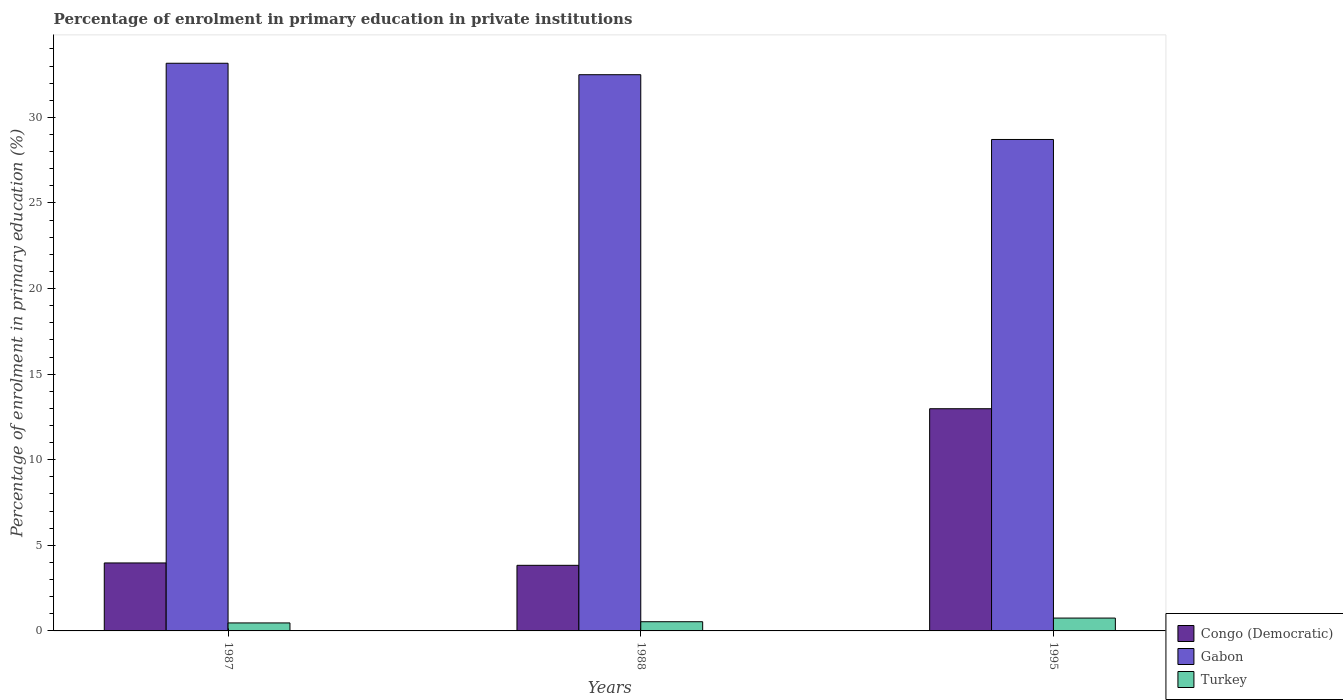Are the number of bars per tick equal to the number of legend labels?
Give a very brief answer. Yes. Are the number of bars on each tick of the X-axis equal?
Offer a very short reply. Yes. How many bars are there on the 1st tick from the right?
Provide a succinct answer. 3. In how many cases, is the number of bars for a given year not equal to the number of legend labels?
Your answer should be compact. 0. What is the percentage of enrolment in primary education in Congo (Democratic) in 1988?
Offer a very short reply. 3.83. Across all years, what is the maximum percentage of enrolment in primary education in Congo (Democratic)?
Provide a succinct answer. 12.98. Across all years, what is the minimum percentage of enrolment in primary education in Congo (Democratic)?
Your answer should be compact. 3.83. In which year was the percentage of enrolment in primary education in Gabon maximum?
Your response must be concise. 1987. What is the total percentage of enrolment in primary education in Congo (Democratic) in the graph?
Keep it short and to the point. 20.78. What is the difference between the percentage of enrolment in primary education in Gabon in 1988 and that in 1995?
Make the answer very short. 3.78. What is the difference between the percentage of enrolment in primary education in Gabon in 1987 and the percentage of enrolment in primary education in Congo (Democratic) in 1995?
Ensure brevity in your answer.  20.18. What is the average percentage of enrolment in primary education in Gabon per year?
Provide a short and direct response. 31.45. In the year 1995, what is the difference between the percentage of enrolment in primary education in Gabon and percentage of enrolment in primary education in Congo (Democratic)?
Give a very brief answer. 15.73. In how many years, is the percentage of enrolment in primary education in Turkey greater than 22 %?
Ensure brevity in your answer.  0. What is the ratio of the percentage of enrolment in primary education in Congo (Democratic) in 1987 to that in 1988?
Provide a succinct answer. 1.04. Is the difference between the percentage of enrolment in primary education in Gabon in 1987 and 1995 greater than the difference between the percentage of enrolment in primary education in Congo (Democratic) in 1987 and 1995?
Your answer should be very brief. Yes. What is the difference between the highest and the second highest percentage of enrolment in primary education in Gabon?
Offer a very short reply. 0.67. What is the difference between the highest and the lowest percentage of enrolment in primary education in Congo (Democratic)?
Your answer should be very brief. 9.15. What does the 1st bar from the left in 1995 represents?
Offer a terse response. Congo (Democratic). What does the 2nd bar from the right in 1995 represents?
Provide a short and direct response. Gabon. Is it the case that in every year, the sum of the percentage of enrolment in primary education in Turkey and percentage of enrolment in primary education in Gabon is greater than the percentage of enrolment in primary education in Congo (Democratic)?
Your answer should be compact. Yes. How many bars are there?
Provide a short and direct response. 9. Are all the bars in the graph horizontal?
Provide a succinct answer. No. What is the difference between two consecutive major ticks on the Y-axis?
Make the answer very short. 5. Does the graph contain grids?
Offer a very short reply. No. How many legend labels are there?
Keep it short and to the point. 3. How are the legend labels stacked?
Ensure brevity in your answer.  Vertical. What is the title of the graph?
Ensure brevity in your answer.  Percentage of enrolment in primary education in private institutions. What is the label or title of the Y-axis?
Provide a succinct answer. Percentage of enrolment in primary education (%). What is the Percentage of enrolment in primary education (%) of Congo (Democratic) in 1987?
Provide a succinct answer. 3.97. What is the Percentage of enrolment in primary education (%) in Gabon in 1987?
Your answer should be very brief. 33.16. What is the Percentage of enrolment in primary education (%) in Turkey in 1987?
Keep it short and to the point. 0.47. What is the Percentage of enrolment in primary education (%) in Congo (Democratic) in 1988?
Your answer should be compact. 3.83. What is the Percentage of enrolment in primary education (%) in Gabon in 1988?
Offer a very short reply. 32.49. What is the Percentage of enrolment in primary education (%) of Turkey in 1988?
Provide a succinct answer. 0.54. What is the Percentage of enrolment in primary education (%) of Congo (Democratic) in 1995?
Your answer should be very brief. 12.98. What is the Percentage of enrolment in primary education (%) of Gabon in 1995?
Offer a very short reply. 28.71. What is the Percentage of enrolment in primary education (%) of Turkey in 1995?
Provide a succinct answer. 0.75. Across all years, what is the maximum Percentage of enrolment in primary education (%) of Congo (Democratic)?
Make the answer very short. 12.98. Across all years, what is the maximum Percentage of enrolment in primary education (%) in Gabon?
Ensure brevity in your answer.  33.16. Across all years, what is the maximum Percentage of enrolment in primary education (%) in Turkey?
Provide a succinct answer. 0.75. Across all years, what is the minimum Percentage of enrolment in primary education (%) in Congo (Democratic)?
Keep it short and to the point. 3.83. Across all years, what is the minimum Percentage of enrolment in primary education (%) of Gabon?
Your answer should be compact. 28.71. Across all years, what is the minimum Percentage of enrolment in primary education (%) in Turkey?
Offer a terse response. 0.47. What is the total Percentage of enrolment in primary education (%) in Congo (Democratic) in the graph?
Make the answer very short. 20.78. What is the total Percentage of enrolment in primary education (%) in Gabon in the graph?
Ensure brevity in your answer.  94.36. What is the total Percentage of enrolment in primary education (%) in Turkey in the graph?
Provide a succinct answer. 1.75. What is the difference between the Percentage of enrolment in primary education (%) of Congo (Democratic) in 1987 and that in 1988?
Give a very brief answer. 0.14. What is the difference between the Percentage of enrolment in primary education (%) in Gabon in 1987 and that in 1988?
Provide a succinct answer. 0.67. What is the difference between the Percentage of enrolment in primary education (%) in Turkey in 1987 and that in 1988?
Offer a very short reply. -0.07. What is the difference between the Percentage of enrolment in primary education (%) of Congo (Democratic) in 1987 and that in 1995?
Ensure brevity in your answer.  -9.01. What is the difference between the Percentage of enrolment in primary education (%) of Gabon in 1987 and that in 1995?
Keep it short and to the point. 4.45. What is the difference between the Percentage of enrolment in primary education (%) in Turkey in 1987 and that in 1995?
Your response must be concise. -0.28. What is the difference between the Percentage of enrolment in primary education (%) in Congo (Democratic) in 1988 and that in 1995?
Provide a short and direct response. -9.15. What is the difference between the Percentage of enrolment in primary education (%) of Gabon in 1988 and that in 1995?
Provide a succinct answer. 3.78. What is the difference between the Percentage of enrolment in primary education (%) of Turkey in 1988 and that in 1995?
Your answer should be compact. -0.21. What is the difference between the Percentage of enrolment in primary education (%) of Congo (Democratic) in 1987 and the Percentage of enrolment in primary education (%) of Gabon in 1988?
Provide a succinct answer. -28.52. What is the difference between the Percentage of enrolment in primary education (%) of Congo (Democratic) in 1987 and the Percentage of enrolment in primary education (%) of Turkey in 1988?
Offer a terse response. 3.43. What is the difference between the Percentage of enrolment in primary education (%) of Gabon in 1987 and the Percentage of enrolment in primary education (%) of Turkey in 1988?
Offer a very short reply. 32.62. What is the difference between the Percentage of enrolment in primary education (%) of Congo (Democratic) in 1987 and the Percentage of enrolment in primary education (%) of Gabon in 1995?
Your answer should be compact. -24.74. What is the difference between the Percentage of enrolment in primary education (%) in Congo (Democratic) in 1987 and the Percentage of enrolment in primary education (%) in Turkey in 1995?
Offer a very short reply. 3.22. What is the difference between the Percentage of enrolment in primary education (%) in Gabon in 1987 and the Percentage of enrolment in primary education (%) in Turkey in 1995?
Make the answer very short. 32.41. What is the difference between the Percentage of enrolment in primary education (%) in Congo (Democratic) in 1988 and the Percentage of enrolment in primary education (%) in Gabon in 1995?
Your answer should be very brief. -24.88. What is the difference between the Percentage of enrolment in primary education (%) in Congo (Democratic) in 1988 and the Percentage of enrolment in primary education (%) in Turkey in 1995?
Provide a short and direct response. 3.08. What is the difference between the Percentage of enrolment in primary education (%) in Gabon in 1988 and the Percentage of enrolment in primary education (%) in Turkey in 1995?
Provide a succinct answer. 31.74. What is the average Percentage of enrolment in primary education (%) in Congo (Democratic) per year?
Provide a short and direct response. 6.93. What is the average Percentage of enrolment in primary education (%) in Gabon per year?
Provide a succinct answer. 31.45. What is the average Percentage of enrolment in primary education (%) in Turkey per year?
Offer a very short reply. 0.58. In the year 1987, what is the difference between the Percentage of enrolment in primary education (%) in Congo (Democratic) and Percentage of enrolment in primary education (%) in Gabon?
Provide a short and direct response. -29.19. In the year 1987, what is the difference between the Percentage of enrolment in primary education (%) in Congo (Democratic) and Percentage of enrolment in primary education (%) in Turkey?
Offer a very short reply. 3.5. In the year 1987, what is the difference between the Percentage of enrolment in primary education (%) in Gabon and Percentage of enrolment in primary education (%) in Turkey?
Your answer should be very brief. 32.69. In the year 1988, what is the difference between the Percentage of enrolment in primary education (%) in Congo (Democratic) and Percentage of enrolment in primary education (%) in Gabon?
Keep it short and to the point. -28.66. In the year 1988, what is the difference between the Percentage of enrolment in primary education (%) of Congo (Democratic) and Percentage of enrolment in primary education (%) of Turkey?
Make the answer very short. 3.29. In the year 1988, what is the difference between the Percentage of enrolment in primary education (%) in Gabon and Percentage of enrolment in primary education (%) in Turkey?
Give a very brief answer. 31.95. In the year 1995, what is the difference between the Percentage of enrolment in primary education (%) in Congo (Democratic) and Percentage of enrolment in primary education (%) in Gabon?
Ensure brevity in your answer.  -15.73. In the year 1995, what is the difference between the Percentage of enrolment in primary education (%) in Congo (Democratic) and Percentage of enrolment in primary education (%) in Turkey?
Your response must be concise. 12.23. In the year 1995, what is the difference between the Percentage of enrolment in primary education (%) in Gabon and Percentage of enrolment in primary education (%) in Turkey?
Offer a terse response. 27.96. What is the ratio of the Percentage of enrolment in primary education (%) in Congo (Democratic) in 1987 to that in 1988?
Offer a terse response. 1.04. What is the ratio of the Percentage of enrolment in primary education (%) in Gabon in 1987 to that in 1988?
Your answer should be very brief. 1.02. What is the ratio of the Percentage of enrolment in primary education (%) of Turkey in 1987 to that in 1988?
Keep it short and to the point. 0.87. What is the ratio of the Percentage of enrolment in primary education (%) in Congo (Democratic) in 1987 to that in 1995?
Ensure brevity in your answer.  0.31. What is the ratio of the Percentage of enrolment in primary education (%) in Gabon in 1987 to that in 1995?
Your response must be concise. 1.16. What is the ratio of the Percentage of enrolment in primary education (%) of Turkey in 1987 to that in 1995?
Offer a terse response. 0.62. What is the ratio of the Percentage of enrolment in primary education (%) in Congo (Democratic) in 1988 to that in 1995?
Offer a terse response. 0.3. What is the ratio of the Percentage of enrolment in primary education (%) in Gabon in 1988 to that in 1995?
Give a very brief answer. 1.13. What is the ratio of the Percentage of enrolment in primary education (%) in Turkey in 1988 to that in 1995?
Your answer should be very brief. 0.72. What is the difference between the highest and the second highest Percentage of enrolment in primary education (%) in Congo (Democratic)?
Provide a succinct answer. 9.01. What is the difference between the highest and the second highest Percentage of enrolment in primary education (%) of Gabon?
Give a very brief answer. 0.67. What is the difference between the highest and the second highest Percentage of enrolment in primary education (%) in Turkey?
Offer a very short reply. 0.21. What is the difference between the highest and the lowest Percentage of enrolment in primary education (%) in Congo (Democratic)?
Give a very brief answer. 9.15. What is the difference between the highest and the lowest Percentage of enrolment in primary education (%) in Gabon?
Make the answer very short. 4.45. What is the difference between the highest and the lowest Percentage of enrolment in primary education (%) of Turkey?
Offer a very short reply. 0.28. 